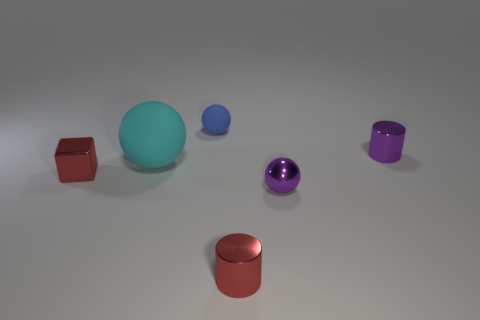Is there anything else that has the same shape as the big cyan thing?
Your answer should be very brief. Yes. There is a tiny red metal object that is on the right side of the red shiny object that is to the left of the small matte ball; what is its shape?
Make the answer very short. Cylinder. What shape is the cyan object that is made of the same material as the small blue thing?
Keep it short and to the point. Sphere. How big is the red metallic object that is in front of the shiny thing on the left side of the tiny blue sphere?
Provide a short and direct response. Small. The tiny blue object is what shape?
Offer a very short reply. Sphere. How many big things are red shiny cylinders or cyan shiny blocks?
Provide a short and direct response. 0. The purple thing that is the same shape as the blue matte thing is what size?
Keep it short and to the point. Small. What number of tiny objects are to the right of the tiny red cube and in front of the small blue thing?
Offer a very short reply. 3. There is a tiny blue object; is it the same shape as the red object to the right of the cyan rubber ball?
Provide a succinct answer. No. Are there more balls that are behind the purple metallic ball than tiny purple cylinders?
Provide a succinct answer. Yes. 